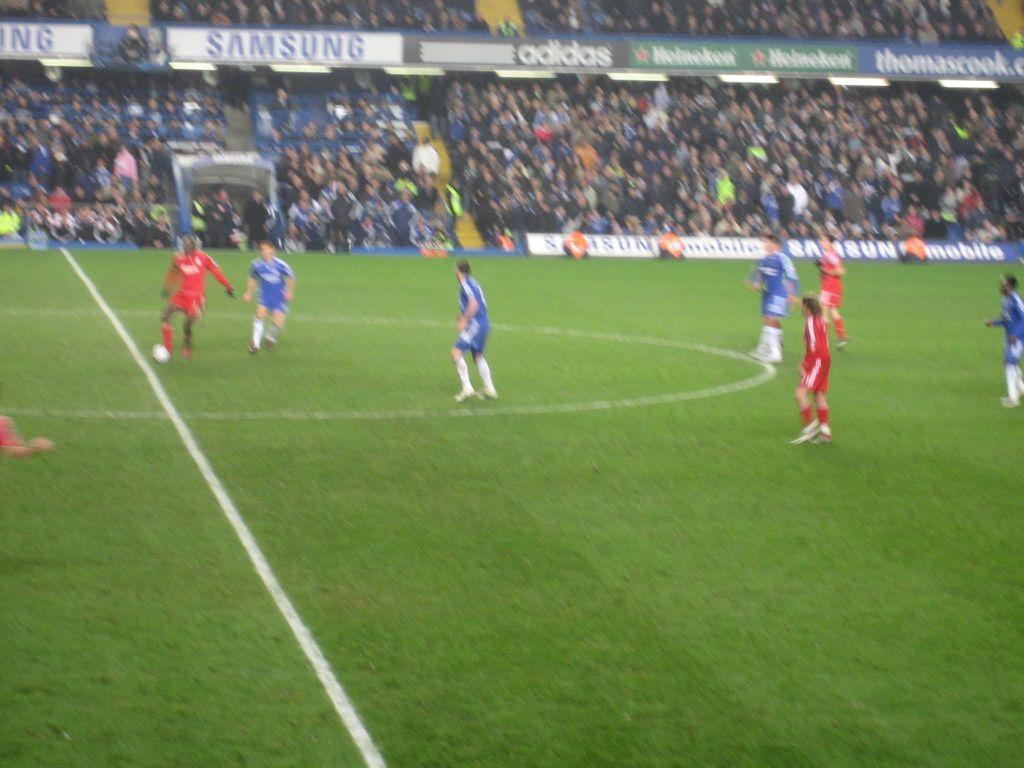<image>
Offer a succinct explanation of the picture presented. A Samsung logo can be seen in a soccer stadium. 